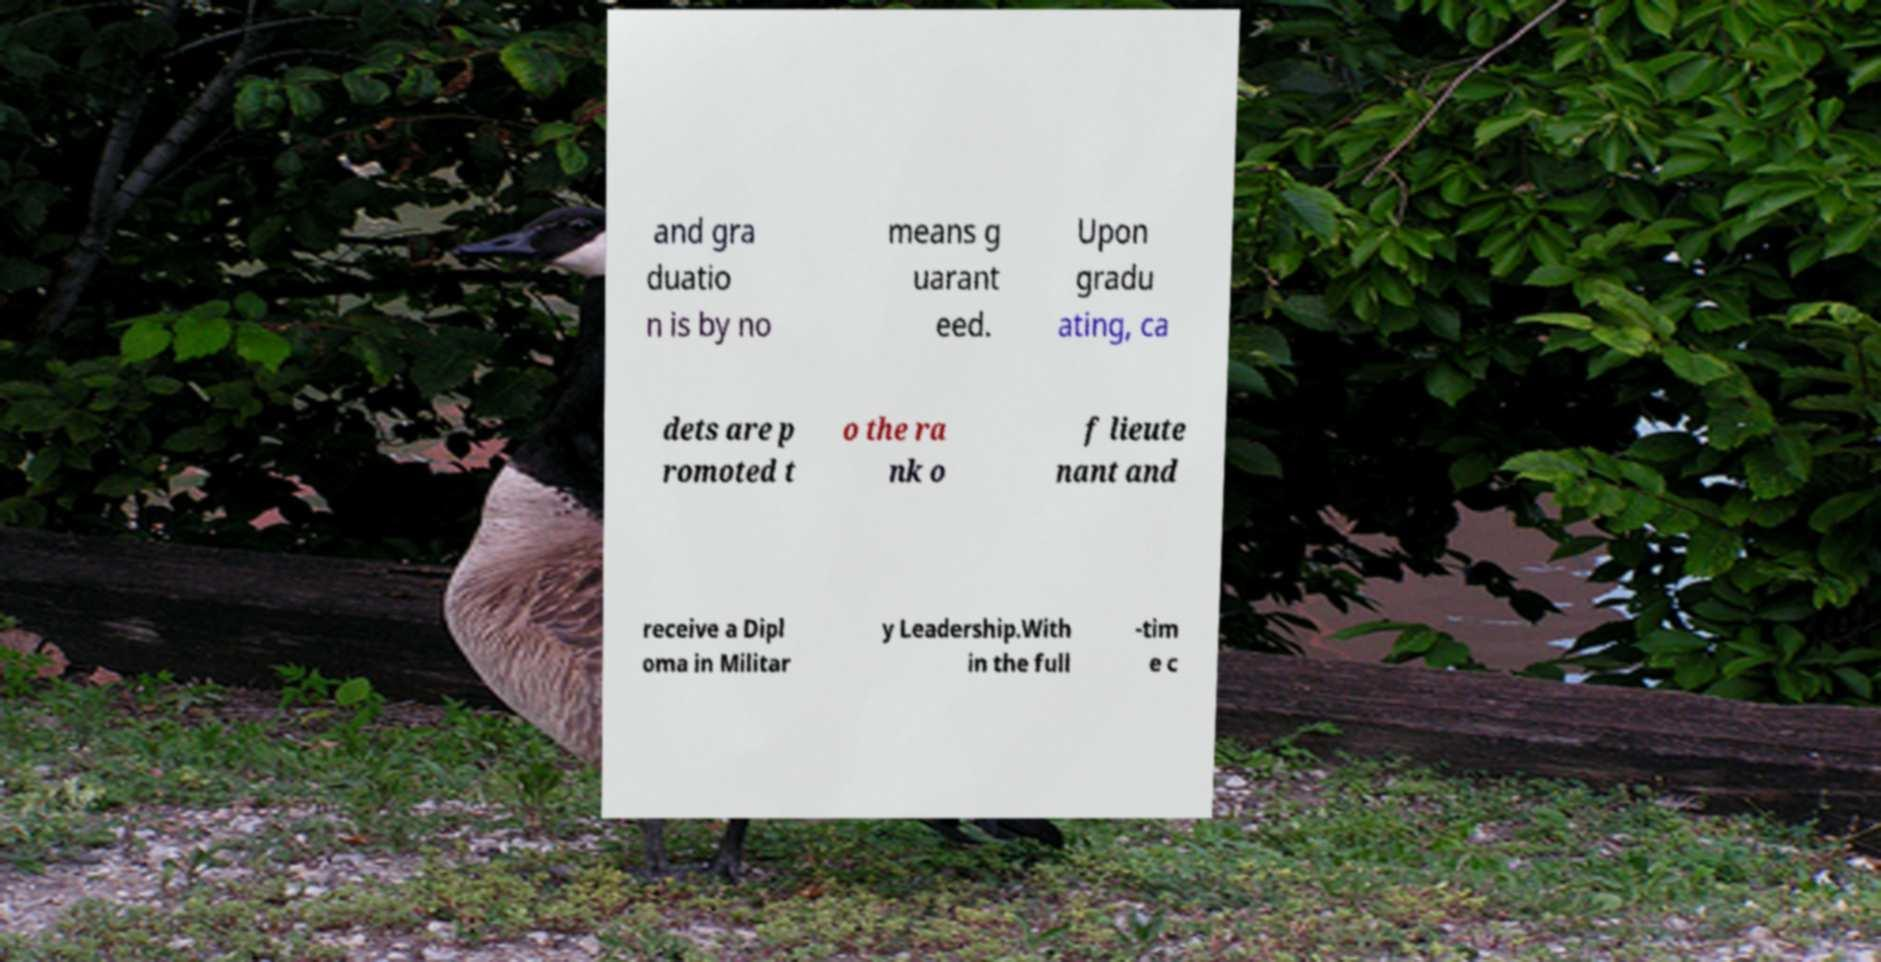Can you accurately transcribe the text from the provided image for me? and gra duatio n is by no means g uarant eed. Upon gradu ating, ca dets are p romoted t o the ra nk o f lieute nant and receive a Dipl oma in Militar y Leadership.With in the full -tim e c 